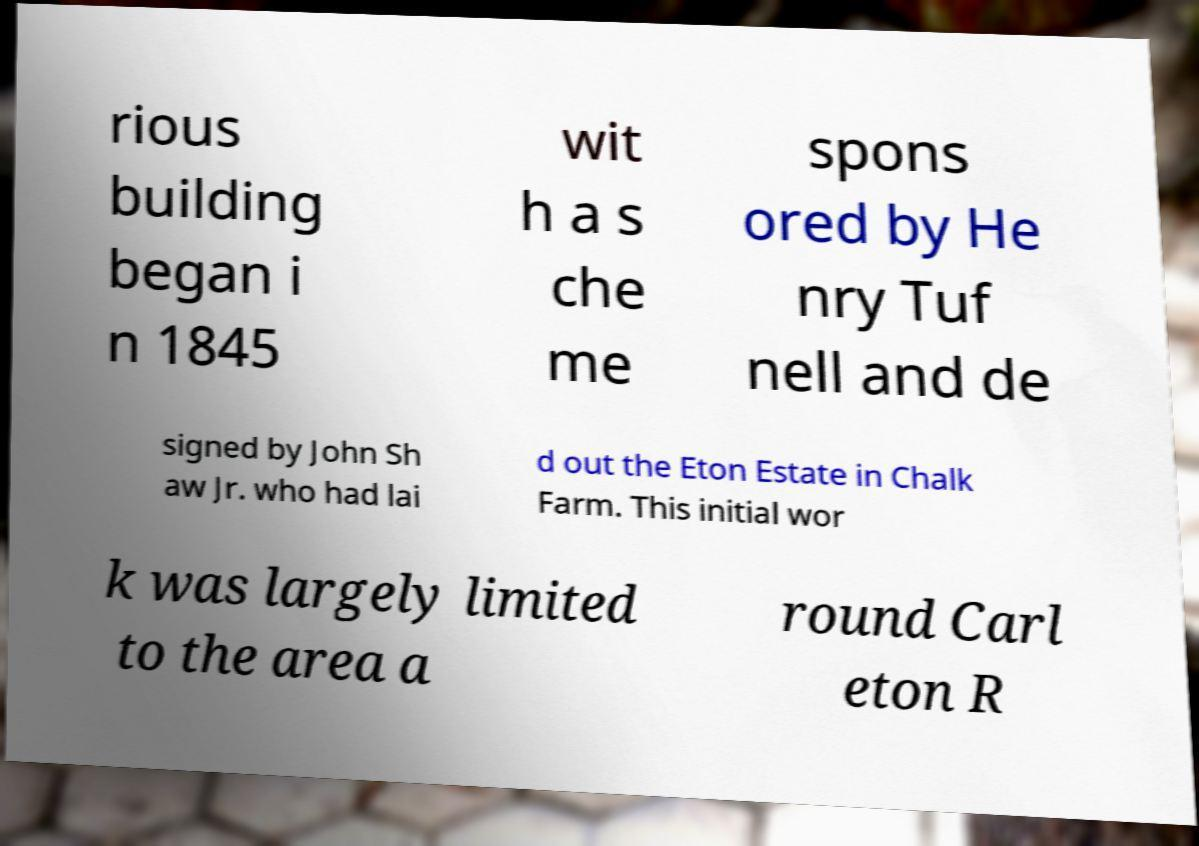For documentation purposes, I need the text within this image transcribed. Could you provide that? rious building began i n 1845 wit h a s che me spons ored by He nry Tuf nell and de signed by John Sh aw Jr. who had lai d out the Eton Estate in Chalk Farm. This initial wor k was largely limited to the area a round Carl eton R 